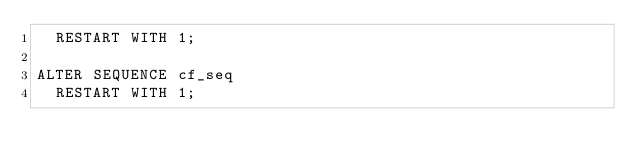<code> <loc_0><loc_0><loc_500><loc_500><_SQL_>  RESTART WITH 1;

ALTER SEQUENCE cf_seq
  RESTART WITH 1;
</code> 